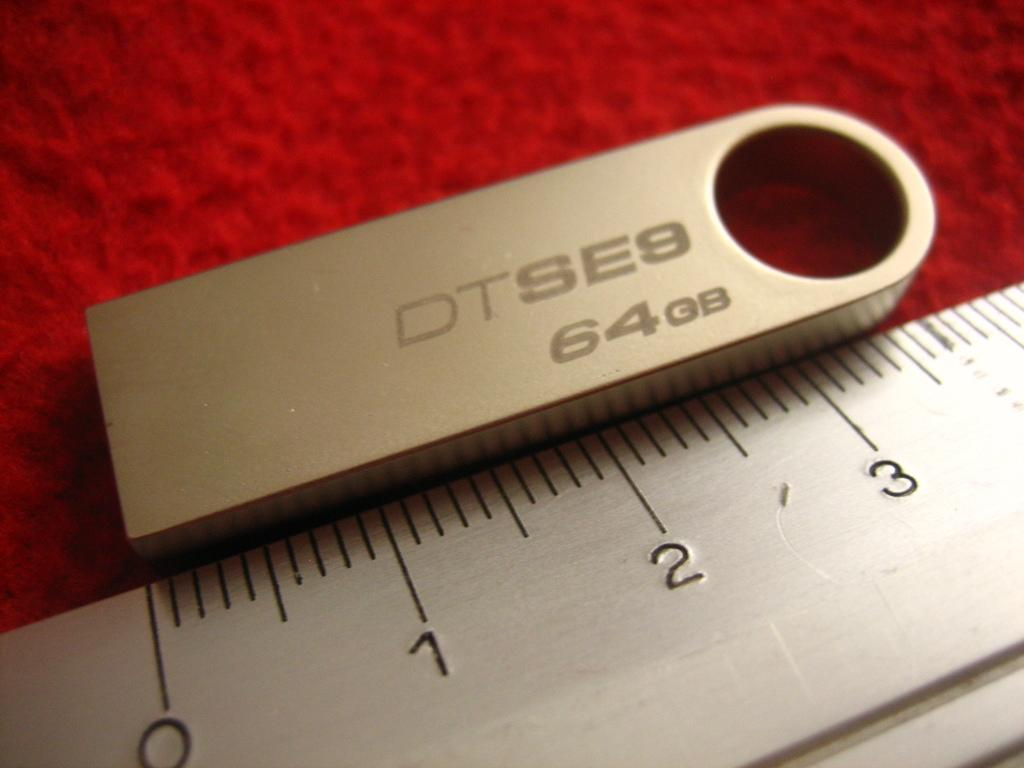<image>
Offer a succinct explanation of the picture presented. a measurement device with 1 to 3 shown on ut 